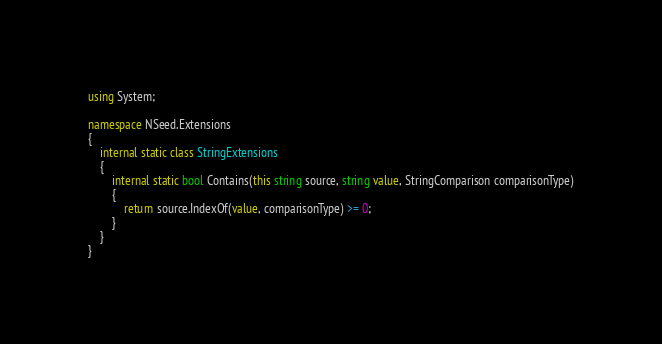<code> <loc_0><loc_0><loc_500><loc_500><_C#_>using System;

namespace NSeed.Extensions
{
    internal static class StringExtensions
    {
        internal static bool Contains(this string source, string value, StringComparison comparisonType)
        {
            return source.IndexOf(value, comparisonType) >= 0;
        }
    }
}
</code> 